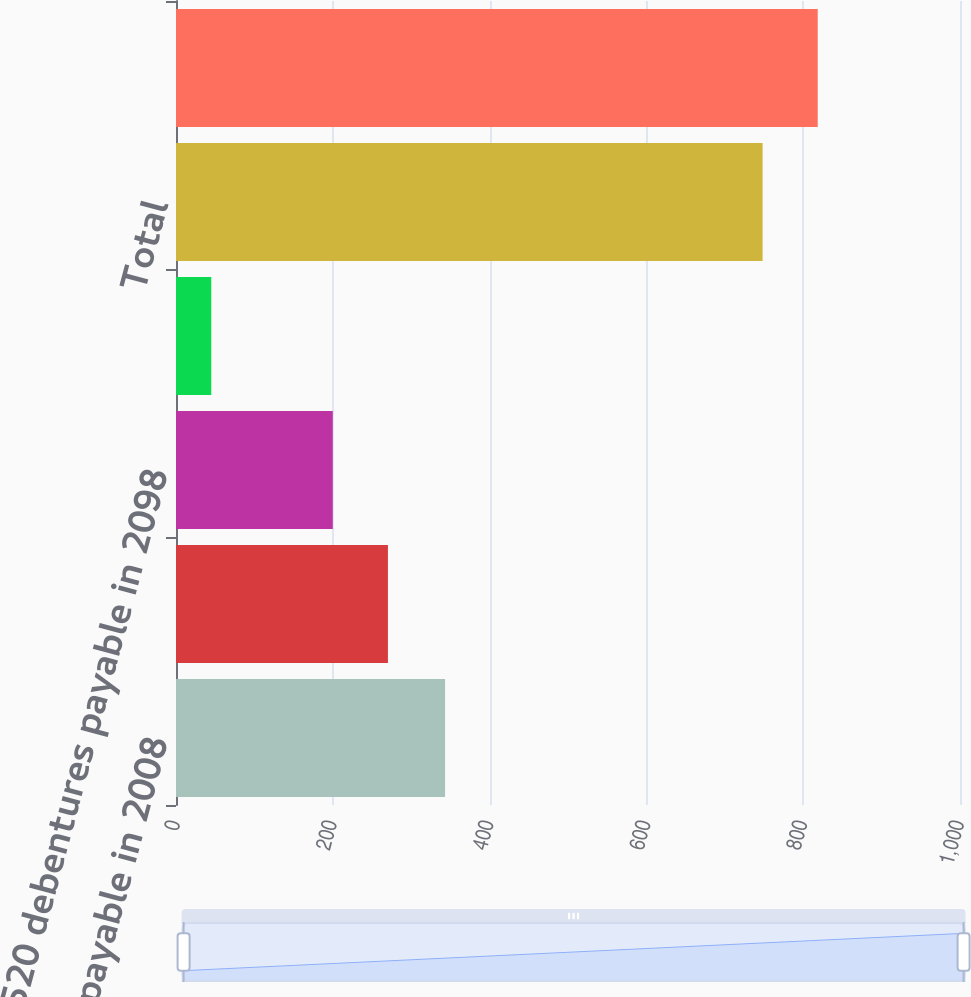<chart> <loc_0><loc_0><loc_500><loc_500><bar_chart><fcel>615 notes payable in 2008<fcel>670 debentures payable in 2028<fcel>520 debentures payable in 2098<fcel>Unamortized discount and other<fcel>Total<fcel>Long-term debt<nl><fcel>343.2<fcel>270.32<fcel>200<fcel>45<fcel>748.2<fcel>818.52<nl></chart> 